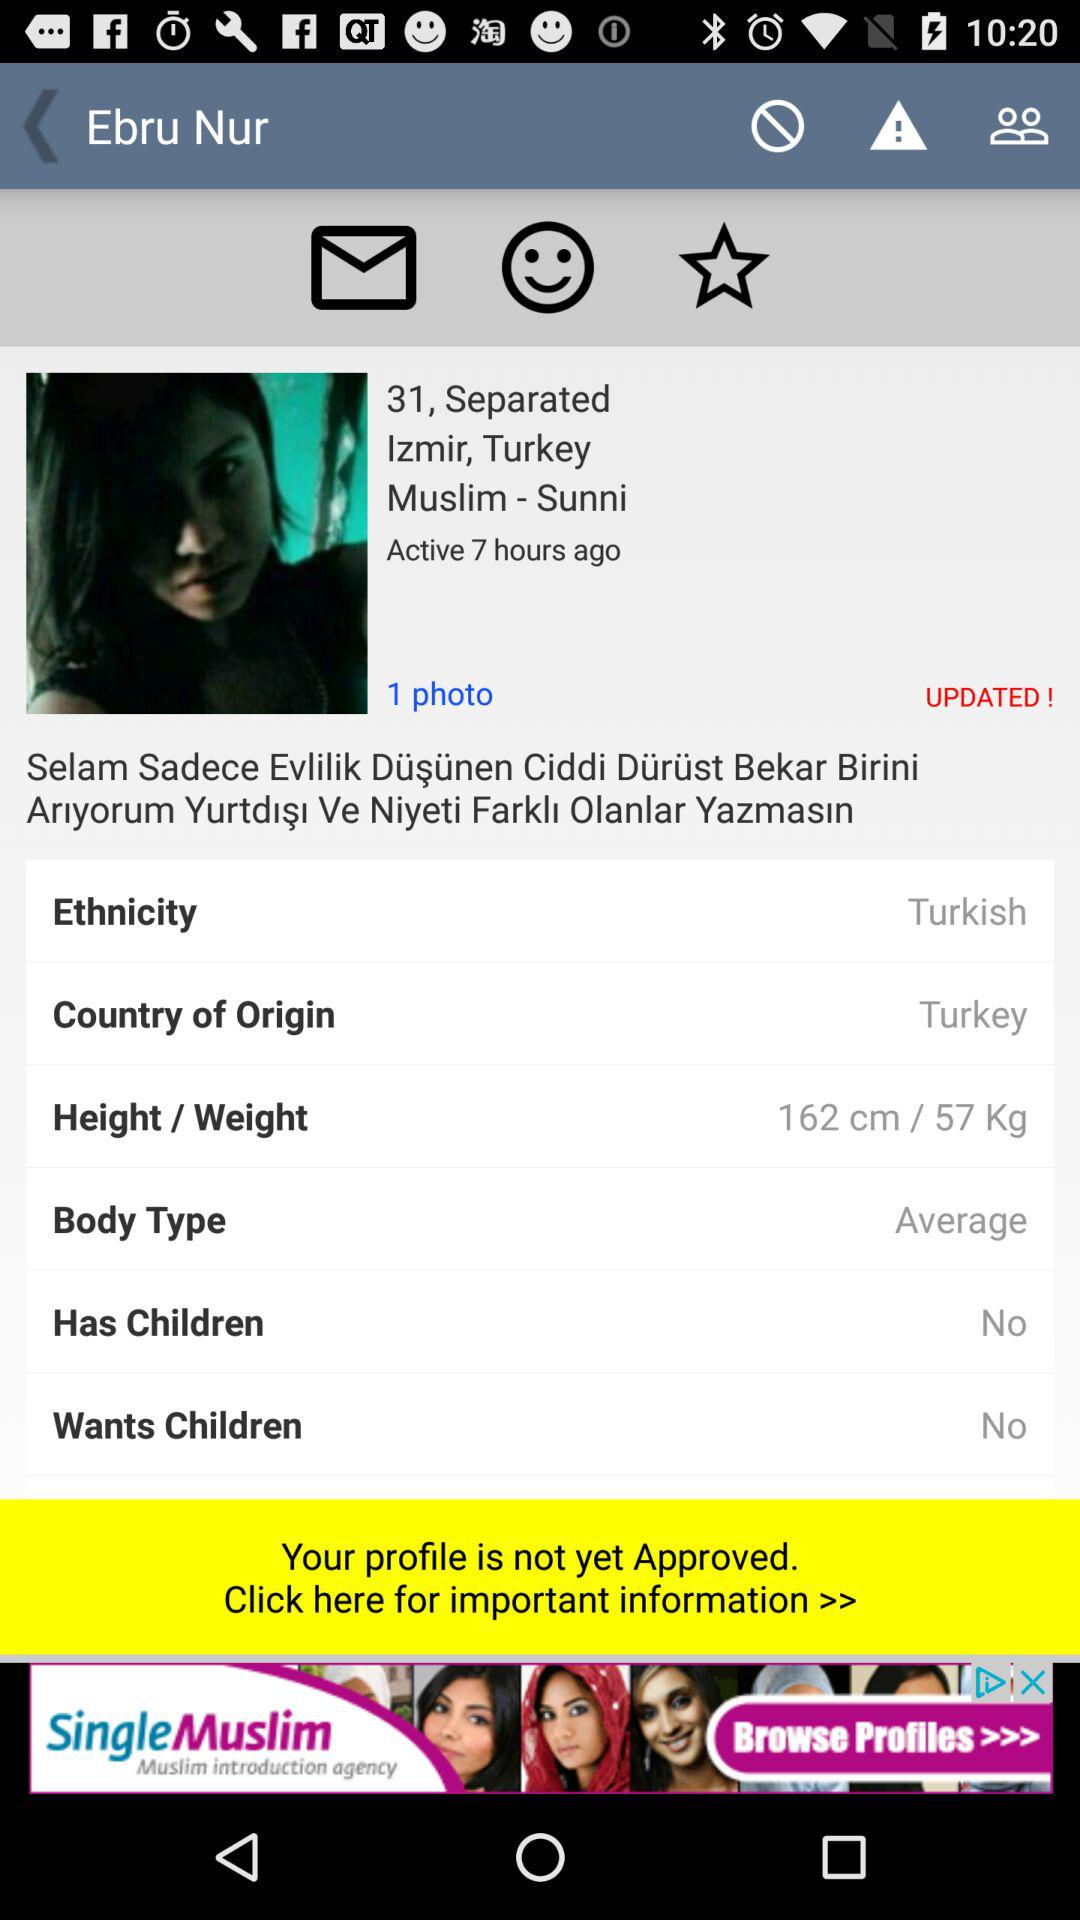What is the ethnicity? The ethnicity is "Turkish". 